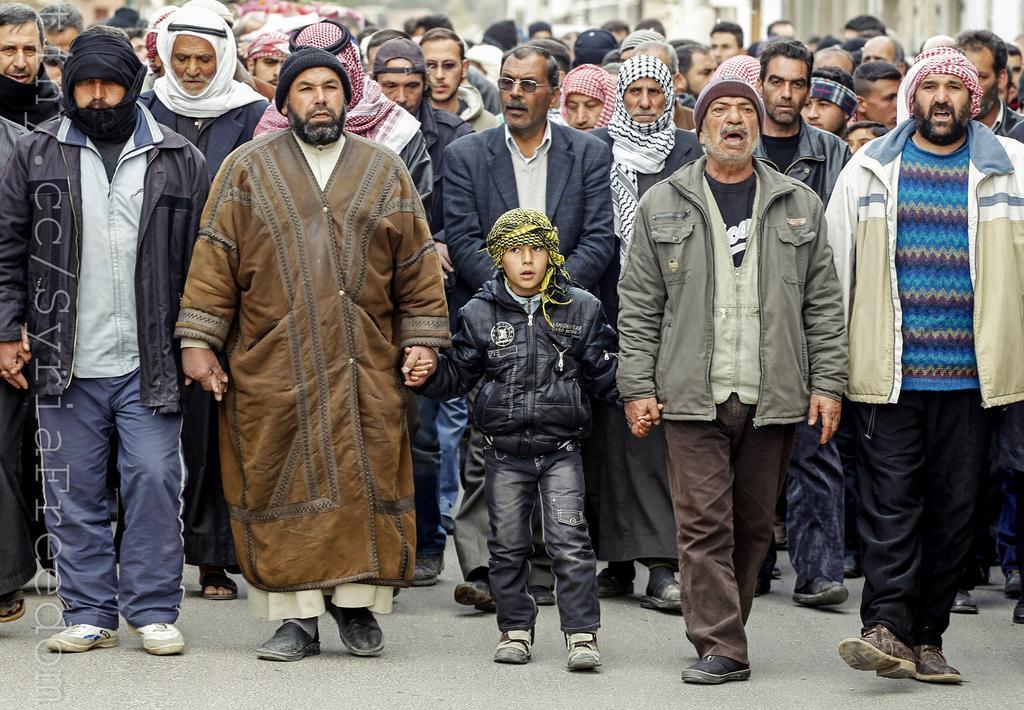In one or two sentences, can you explain what this image depicts? As we can see in the image in the front there are group of standing and in the background there are buildings. 